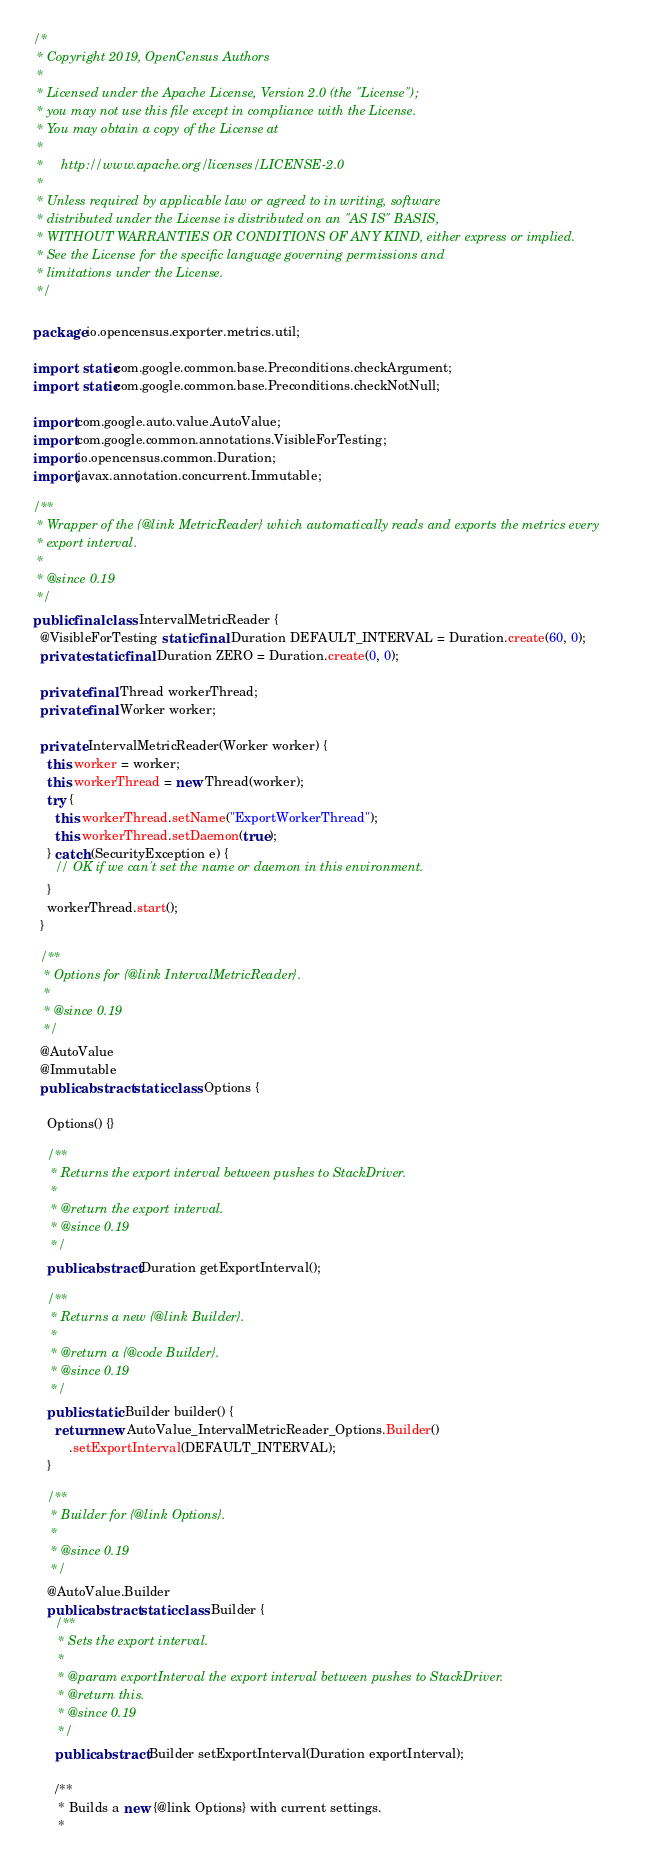Convert code to text. <code><loc_0><loc_0><loc_500><loc_500><_Java_>/*
 * Copyright 2019, OpenCensus Authors
 *
 * Licensed under the Apache License, Version 2.0 (the "License");
 * you may not use this file except in compliance with the License.
 * You may obtain a copy of the License at
 *
 *     http://www.apache.org/licenses/LICENSE-2.0
 *
 * Unless required by applicable law or agreed to in writing, software
 * distributed under the License is distributed on an "AS IS" BASIS,
 * WITHOUT WARRANTIES OR CONDITIONS OF ANY KIND, either express or implied.
 * See the License for the specific language governing permissions and
 * limitations under the License.
 */

package io.opencensus.exporter.metrics.util;

import static com.google.common.base.Preconditions.checkArgument;
import static com.google.common.base.Preconditions.checkNotNull;

import com.google.auto.value.AutoValue;
import com.google.common.annotations.VisibleForTesting;
import io.opencensus.common.Duration;
import javax.annotation.concurrent.Immutable;

/**
 * Wrapper of the {@link MetricReader} which automatically reads and exports the metrics every
 * export interval.
 *
 * @since 0.19
 */
public final class IntervalMetricReader {
  @VisibleForTesting static final Duration DEFAULT_INTERVAL = Duration.create(60, 0);
  private static final Duration ZERO = Duration.create(0, 0);

  private final Thread workerThread;
  private final Worker worker;

  private IntervalMetricReader(Worker worker) {
    this.worker = worker;
    this.workerThread = new Thread(worker);
    try {
      this.workerThread.setName("ExportWorkerThread");
      this.workerThread.setDaemon(true);
    } catch (SecurityException e) {
      // OK if we can't set the name or daemon in this environment.
    }
    workerThread.start();
  }

  /**
   * Options for {@link IntervalMetricReader}.
   *
   * @since 0.19
   */
  @AutoValue
  @Immutable
  public abstract static class Options {

    Options() {}

    /**
     * Returns the export interval between pushes to StackDriver.
     *
     * @return the export interval.
     * @since 0.19
     */
    public abstract Duration getExportInterval();

    /**
     * Returns a new {@link Builder}.
     *
     * @return a {@code Builder}.
     * @since 0.19
     */
    public static Builder builder() {
      return new AutoValue_IntervalMetricReader_Options.Builder()
          .setExportInterval(DEFAULT_INTERVAL);
    }

    /**
     * Builder for {@link Options}.
     *
     * @since 0.19
     */
    @AutoValue.Builder
    public abstract static class Builder {
      /**
       * Sets the export interval.
       *
       * @param exportInterval the export interval between pushes to StackDriver.
       * @return this.
       * @since 0.19
       */
      public abstract Builder setExportInterval(Duration exportInterval);

      /**
       * Builds a new {@link Options} with current settings.
       *</code> 